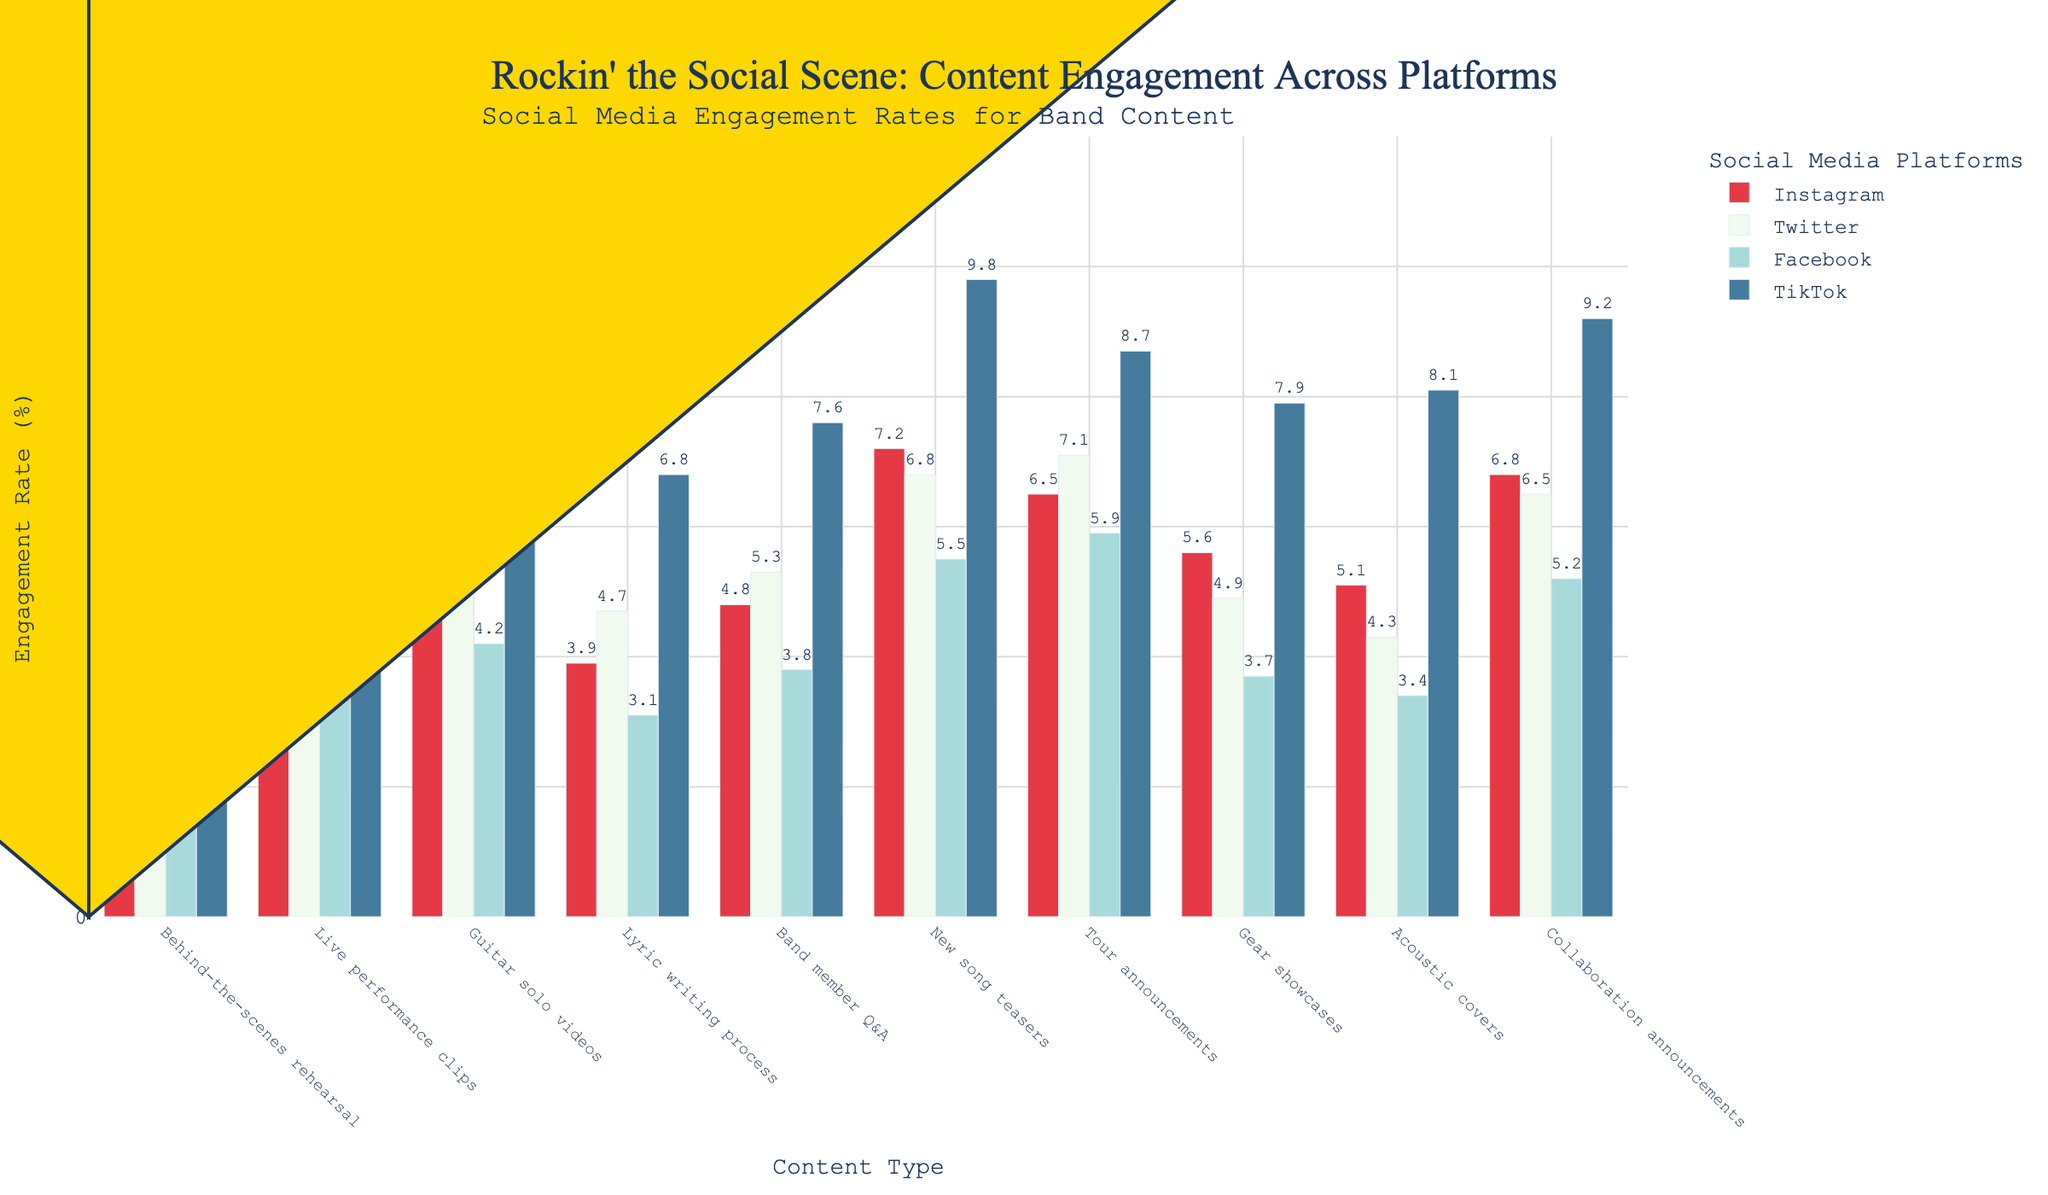Which content type has the highest engagement rate on Instagram? Look at the bars representing different content types on the Instagram axis; the bar for "New song teasers" reaches the highest point.
Answer: New song teasers Which platform has the highest engagement rate for "Guitar solo videos"? Observe the height of the bars corresponding to "Guitar solo videos" across all platforms; the TikTok bar is the tallest.
Answer: TikTok What is the difference in engagement rates for "Live performance clips" between Instagram and Facebook? Subtract the engagement rate of Facebook (3.6) from that of Instagram (5.7).
Answer: 2.1 Which content type has the lowest engagement rate on Twitter? Identify the shortest bar on the Twitter axis; the "Behind-the-scenes rehearsal" bar is the shortest.
Answer: Behind-the-scenes rehearsal What is the average engagement rate for "Tour announcements" across all platforms? Add the engagement rates across Instagram (6.5), Twitter (7.1), Facebook (5.9), and TikTok (8.7); then divide by 4: (6.5 + 7.1 + 5.9 + 8.7) / 4.
Answer: 7.05 Is the engagement rate for "Acoustic covers" on Instagram more than those for "Band member Q&A"? Compare the heights of the bars for "Acoustic covers" (5.1) and "Band member Q&A" (4.8); "Acoustic covers" bar is taller.
Answer: Yes Which color represents engagement rates on TikTok? Refer to the legend on the chart to find the color associated with TikTok.
Answer: Blue What's the sum of engagement rates for "New song teasers" and "Collaboration announcements" on Facebook? Add the engagement rates for "New song teasers" (5.5) and "Collaboration announcements" (5.2) on Facebook: 5.5 + 5.2.
Answer: 10.7 Which platform has the most consistent engagement rates across different content types? By comparing the height variation of bars for each platform, Twitter shows the smallest range of bar heights.
Answer: Twitter 